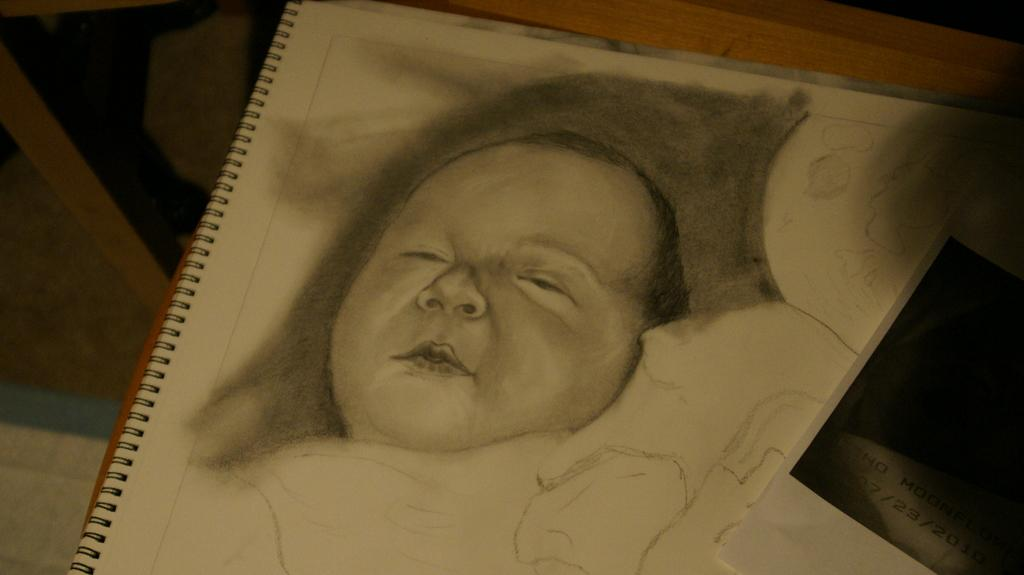What type of artwork is depicted in the image? The image contains a pencil sketch. What is the subject of the sketch? The sketch is of a child. What material is the sketch drawn on? The sketch is on a paper. How many quarters are visible in the image? There are no quarters present in the image; it features a pencil sketch of a child on paper. What type of station is depicted in the image? There is no station depicted in the image; it features a pencil sketch of a child on paper. 